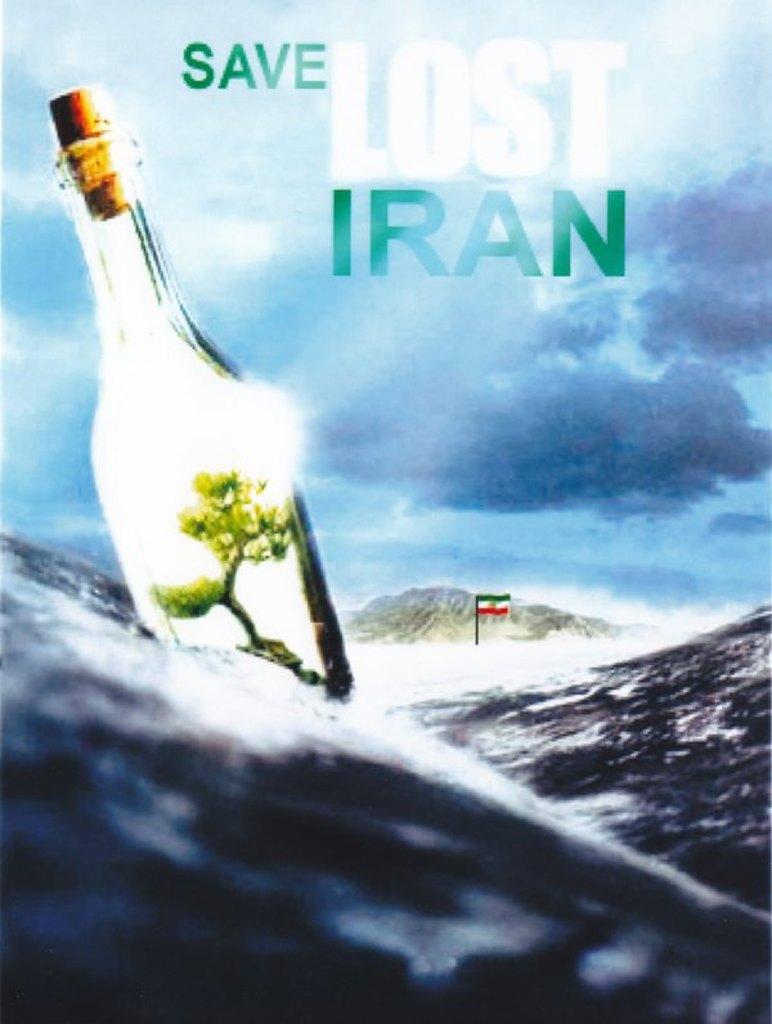What country is the ad asking you to save?
Keep it short and to the point. Iran. 